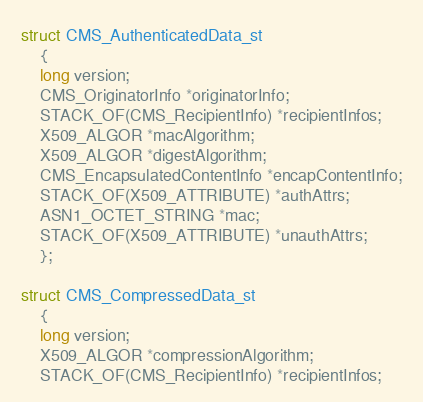Convert code to text. <code><loc_0><loc_0><loc_500><loc_500><_C_>
struct CMS_AuthenticatedData_st
	{
	long version;
	CMS_OriginatorInfo *originatorInfo;
	STACK_OF(CMS_RecipientInfo) *recipientInfos;
	X509_ALGOR *macAlgorithm;
	X509_ALGOR *digestAlgorithm;
	CMS_EncapsulatedContentInfo *encapContentInfo;
	STACK_OF(X509_ATTRIBUTE) *authAttrs;
	ASN1_OCTET_STRING *mac;
	STACK_OF(X509_ATTRIBUTE) *unauthAttrs;
	};

struct CMS_CompressedData_st
	{
	long version;
	X509_ALGOR *compressionAlgorithm;
	STACK_OF(CMS_RecipientInfo) *recipientInfos;</code> 